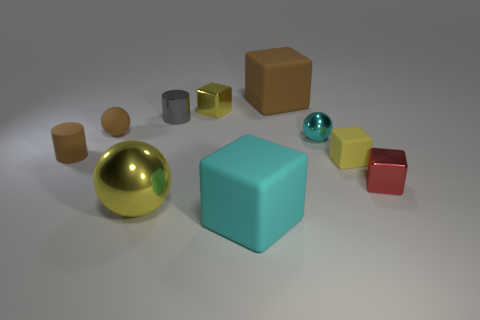Subtract all small rubber blocks. How many blocks are left? 4 Subtract 2 blocks. How many blocks are left? 3 Subtract all red cubes. How many cubes are left? 4 Subtract all blue blocks. Subtract all cyan spheres. How many blocks are left? 5 Subtract all spheres. How many objects are left? 7 Add 6 small red shiny cubes. How many small red shiny cubes are left? 7 Add 4 gray matte balls. How many gray matte balls exist? 4 Subtract 1 brown cylinders. How many objects are left? 9 Subtract all big cyan things. Subtract all small yellow matte objects. How many objects are left? 8 